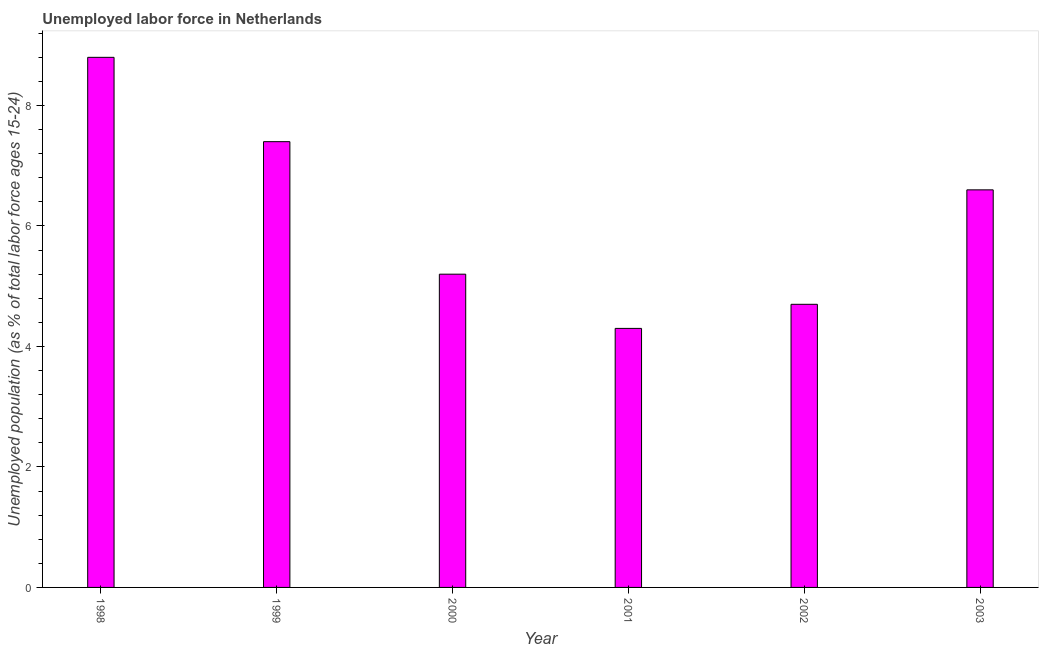Does the graph contain any zero values?
Make the answer very short. No. What is the title of the graph?
Ensure brevity in your answer.  Unemployed labor force in Netherlands. What is the label or title of the X-axis?
Offer a terse response. Year. What is the label or title of the Y-axis?
Keep it short and to the point. Unemployed population (as % of total labor force ages 15-24). What is the total unemployed youth population in 1999?
Your answer should be compact. 7.4. Across all years, what is the maximum total unemployed youth population?
Keep it short and to the point. 8.8. Across all years, what is the minimum total unemployed youth population?
Provide a succinct answer. 4.3. In which year was the total unemployed youth population maximum?
Provide a short and direct response. 1998. In which year was the total unemployed youth population minimum?
Your response must be concise. 2001. What is the sum of the total unemployed youth population?
Offer a terse response. 37. What is the average total unemployed youth population per year?
Your response must be concise. 6.17. What is the median total unemployed youth population?
Offer a terse response. 5.9. In how many years, is the total unemployed youth population greater than 6.4 %?
Provide a short and direct response. 3. Do a majority of the years between 2002 and 1998 (inclusive) have total unemployed youth population greater than 8 %?
Offer a terse response. Yes. What is the ratio of the total unemployed youth population in 2000 to that in 2002?
Provide a succinct answer. 1.11. Is the difference between the total unemployed youth population in 1999 and 2001 greater than the difference between any two years?
Give a very brief answer. No. What is the difference between the highest and the second highest total unemployed youth population?
Give a very brief answer. 1.4. What is the difference between the highest and the lowest total unemployed youth population?
Offer a terse response. 4.5. In how many years, is the total unemployed youth population greater than the average total unemployed youth population taken over all years?
Your answer should be very brief. 3. How many bars are there?
Provide a succinct answer. 6. Are the values on the major ticks of Y-axis written in scientific E-notation?
Your response must be concise. No. What is the Unemployed population (as % of total labor force ages 15-24) of 1998?
Offer a terse response. 8.8. What is the Unemployed population (as % of total labor force ages 15-24) in 1999?
Provide a succinct answer. 7.4. What is the Unemployed population (as % of total labor force ages 15-24) of 2000?
Your response must be concise. 5.2. What is the Unemployed population (as % of total labor force ages 15-24) in 2001?
Keep it short and to the point. 4.3. What is the Unemployed population (as % of total labor force ages 15-24) in 2002?
Provide a short and direct response. 4.7. What is the Unemployed population (as % of total labor force ages 15-24) in 2003?
Your response must be concise. 6.6. What is the difference between the Unemployed population (as % of total labor force ages 15-24) in 1998 and 2001?
Ensure brevity in your answer.  4.5. What is the difference between the Unemployed population (as % of total labor force ages 15-24) in 1999 and 2000?
Offer a terse response. 2.2. What is the difference between the Unemployed population (as % of total labor force ages 15-24) in 1999 and 2003?
Your response must be concise. 0.8. What is the difference between the Unemployed population (as % of total labor force ages 15-24) in 2001 and 2002?
Ensure brevity in your answer.  -0.4. What is the difference between the Unemployed population (as % of total labor force ages 15-24) in 2001 and 2003?
Offer a terse response. -2.3. What is the ratio of the Unemployed population (as % of total labor force ages 15-24) in 1998 to that in 1999?
Your answer should be very brief. 1.19. What is the ratio of the Unemployed population (as % of total labor force ages 15-24) in 1998 to that in 2000?
Offer a very short reply. 1.69. What is the ratio of the Unemployed population (as % of total labor force ages 15-24) in 1998 to that in 2001?
Provide a succinct answer. 2.05. What is the ratio of the Unemployed population (as % of total labor force ages 15-24) in 1998 to that in 2002?
Provide a succinct answer. 1.87. What is the ratio of the Unemployed population (as % of total labor force ages 15-24) in 1998 to that in 2003?
Provide a short and direct response. 1.33. What is the ratio of the Unemployed population (as % of total labor force ages 15-24) in 1999 to that in 2000?
Provide a succinct answer. 1.42. What is the ratio of the Unemployed population (as % of total labor force ages 15-24) in 1999 to that in 2001?
Offer a very short reply. 1.72. What is the ratio of the Unemployed population (as % of total labor force ages 15-24) in 1999 to that in 2002?
Keep it short and to the point. 1.57. What is the ratio of the Unemployed population (as % of total labor force ages 15-24) in 1999 to that in 2003?
Your answer should be very brief. 1.12. What is the ratio of the Unemployed population (as % of total labor force ages 15-24) in 2000 to that in 2001?
Make the answer very short. 1.21. What is the ratio of the Unemployed population (as % of total labor force ages 15-24) in 2000 to that in 2002?
Keep it short and to the point. 1.11. What is the ratio of the Unemployed population (as % of total labor force ages 15-24) in 2000 to that in 2003?
Provide a short and direct response. 0.79. What is the ratio of the Unemployed population (as % of total labor force ages 15-24) in 2001 to that in 2002?
Keep it short and to the point. 0.92. What is the ratio of the Unemployed population (as % of total labor force ages 15-24) in 2001 to that in 2003?
Give a very brief answer. 0.65. What is the ratio of the Unemployed population (as % of total labor force ages 15-24) in 2002 to that in 2003?
Provide a short and direct response. 0.71. 